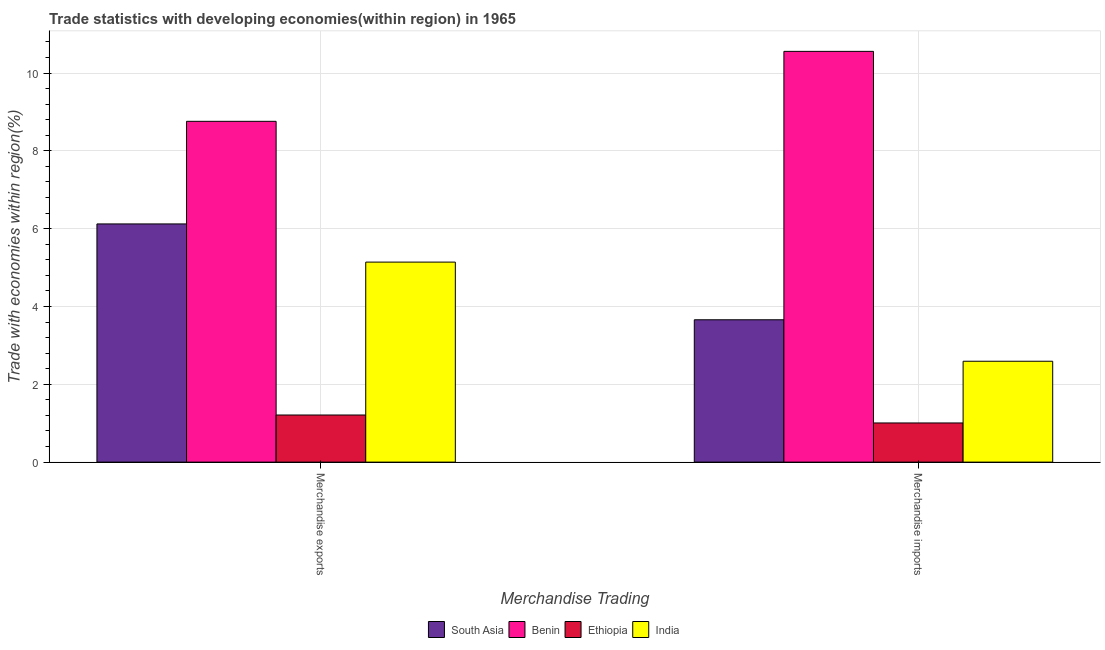How many different coloured bars are there?
Offer a terse response. 4. Are the number of bars on each tick of the X-axis equal?
Make the answer very short. Yes. What is the merchandise imports in South Asia?
Provide a short and direct response. 3.66. Across all countries, what is the maximum merchandise imports?
Ensure brevity in your answer.  10.56. Across all countries, what is the minimum merchandise exports?
Offer a very short reply. 1.21. In which country was the merchandise exports maximum?
Make the answer very short. Benin. In which country was the merchandise imports minimum?
Give a very brief answer. Ethiopia. What is the total merchandise exports in the graph?
Provide a short and direct response. 21.23. What is the difference between the merchandise exports in Benin and that in India?
Make the answer very short. 3.62. What is the difference between the merchandise exports in Benin and the merchandise imports in India?
Offer a terse response. 6.17. What is the average merchandise imports per country?
Your response must be concise. 4.45. What is the difference between the merchandise imports and merchandise exports in Benin?
Make the answer very short. 1.8. In how many countries, is the merchandise imports greater than 0.8 %?
Make the answer very short. 4. What is the ratio of the merchandise exports in Ethiopia to that in India?
Your response must be concise. 0.24. Is the merchandise exports in Ethiopia less than that in India?
Your response must be concise. Yes. What does the 4th bar from the left in Merchandise imports represents?
Give a very brief answer. India. What does the 4th bar from the right in Merchandise exports represents?
Provide a succinct answer. South Asia. How many bars are there?
Provide a succinct answer. 8. How many countries are there in the graph?
Your answer should be very brief. 4. Are the values on the major ticks of Y-axis written in scientific E-notation?
Give a very brief answer. No. Does the graph contain any zero values?
Offer a terse response. No. Where does the legend appear in the graph?
Provide a succinct answer. Bottom center. What is the title of the graph?
Your answer should be very brief. Trade statistics with developing economies(within region) in 1965. Does "Tajikistan" appear as one of the legend labels in the graph?
Provide a short and direct response. No. What is the label or title of the X-axis?
Provide a succinct answer. Merchandise Trading. What is the label or title of the Y-axis?
Offer a very short reply. Trade with economies within region(%). What is the Trade with economies within region(%) of South Asia in Merchandise exports?
Ensure brevity in your answer.  6.12. What is the Trade with economies within region(%) in Benin in Merchandise exports?
Your response must be concise. 8.76. What is the Trade with economies within region(%) of Ethiopia in Merchandise exports?
Your answer should be very brief. 1.21. What is the Trade with economies within region(%) in India in Merchandise exports?
Your answer should be compact. 5.14. What is the Trade with economies within region(%) in South Asia in Merchandise imports?
Offer a terse response. 3.66. What is the Trade with economies within region(%) of Benin in Merchandise imports?
Offer a terse response. 10.56. What is the Trade with economies within region(%) in Ethiopia in Merchandise imports?
Provide a short and direct response. 1.01. What is the Trade with economies within region(%) of India in Merchandise imports?
Your response must be concise. 2.59. Across all Merchandise Trading, what is the maximum Trade with economies within region(%) of South Asia?
Ensure brevity in your answer.  6.12. Across all Merchandise Trading, what is the maximum Trade with economies within region(%) in Benin?
Offer a terse response. 10.56. Across all Merchandise Trading, what is the maximum Trade with economies within region(%) of Ethiopia?
Provide a short and direct response. 1.21. Across all Merchandise Trading, what is the maximum Trade with economies within region(%) of India?
Offer a very short reply. 5.14. Across all Merchandise Trading, what is the minimum Trade with economies within region(%) in South Asia?
Your response must be concise. 3.66. Across all Merchandise Trading, what is the minimum Trade with economies within region(%) in Benin?
Ensure brevity in your answer.  8.76. Across all Merchandise Trading, what is the minimum Trade with economies within region(%) of Ethiopia?
Ensure brevity in your answer.  1.01. Across all Merchandise Trading, what is the minimum Trade with economies within region(%) of India?
Your answer should be very brief. 2.59. What is the total Trade with economies within region(%) of South Asia in the graph?
Your answer should be compact. 9.78. What is the total Trade with economies within region(%) in Benin in the graph?
Give a very brief answer. 19.32. What is the total Trade with economies within region(%) of Ethiopia in the graph?
Ensure brevity in your answer.  2.22. What is the total Trade with economies within region(%) in India in the graph?
Make the answer very short. 7.73. What is the difference between the Trade with economies within region(%) in South Asia in Merchandise exports and that in Merchandise imports?
Provide a succinct answer. 2.46. What is the difference between the Trade with economies within region(%) in Benin in Merchandise exports and that in Merchandise imports?
Offer a terse response. -1.8. What is the difference between the Trade with economies within region(%) of Ethiopia in Merchandise exports and that in Merchandise imports?
Your answer should be very brief. 0.2. What is the difference between the Trade with economies within region(%) in India in Merchandise exports and that in Merchandise imports?
Make the answer very short. 2.55. What is the difference between the Trade with economies within region(%) in South Asia in Merchandise exports and the Trade with economies within region(%) in Benin in Merchandise imports?
Your answer should be very brief. -4.44. What is the difference between the Trade with economies within region(%) of South Asia in Merchandise exports and the Trade with economies within region(%) of Ethiopia in Merchandise imports?
Ensure brevity in your answer.  5.12. What is the difference between the Trade with economies within region(%) of South Asia in Merchandise exports and the Trade with economies within region(%) of India in Merchandise imports?
Offer a very short reply. 3.53. What is the difference between the Trade with economies within region(%) of Benin in Merchandise exports and the Trade with economies within region(%) of Ethiopia in Merchandise imports?
Your answer should be compact. 7.75. What is the difference between the Trade with economies within region(%) in Benin in Merchandise exports and the Trade with economies within region(%) in India in Merchandise imports?
Ensure brevity in your answer.  6.17. What is the difference between the Trade with economies within region(%) of Ethiopia in Merchandise exports and the Trade with economies within region(%) of India in Merchandise imports?
Your response must be concise. -1.38. What is the average Trade with economies within region(%) in South Asia per Merchandise Trading?
Ensure brevity in your answer.  4.89. What is the average Trade with economies within region(%) in Benin per Merchandise Trading?
Keep it short and to the point. 9.66. What is the average Trade with economies within region(%) in Ethiopia per Merchandise Trading?
Offer a very short reply. 1.11. What is the average Trade with economies within region(%) in India per Merchandise Trading?
Your response must be concise. 3.87. What is the difference between the Trade with economies within region(%) of South Asia and Trade with economies within region(%) of Benin in Merchandise exports?
Your response must be concise. -2.64. What is the difference between the Trade with economies within region(%) of South Asia and Trade with economies within region(%) of Ethiopia in Merchandise exports?
Ensure brevity in your answer.  4.91. What is the difference between the Trade with economies within region(%) in South Asia and Trade with economies within region(%) in India in Merchandise exports?
Make the answer very short. 0.98. What is the difference between the Trade with economies within region(%) in Benin and Trade with economies within region(%) in Ethiopia in Merchandise exports?
Ensure brevity in your answer.  7.55. What is the difference between the Trade with economies within region(%) in Benin and Trade with economies within region(%) in India in Merchandise exports?
Offer a very short reply. 3.62. What is the difference between the Trade with economies within region(%) of Ethiopia and Trade with economies within region(%) of India in Merchandise exports?
Your answer should be very brief. -3.93. What is the difference between the Trade with economies within region(%) in South Asia and Trade with economies within region(%) in Benin in Merchandise imports?
Offer a terse response. -6.9. What is the difference between the Trade with economies within region(%) of South Asia and Trade with economies within region(%) of Ethiopia in Merchandise imports?
Provide a succinct answer. 2.65. What is the difference between the Trade with economies within region(%) in South Asia and Trade with economies within region(%) in India in Merchandise imports?
Offer a very short reply. 1.07. What is the difference between the Trade with economies within region(%) of Benin and Trade with economies within region(%) of Ethiopia in Merchandise imports?
Give a very brief answer. 9.55. What is the difference between the Trade with economies within region(%) in Benin and Trade with economies within region(%) in India in Merchandise imports?
Provide a short and direct response. 7.96. What is the difference between the Trade with economies within region(%) in Ethiopia and Trade with economies within region(%) in India in Merchandise imports?
Ensure brevity in your answer.  -1.59. What is the ratio of the Trade with economies within region(%) of South Asia in Merchandise exports to that in Merchandise imports?
Your response must be concise. 1.67. What is the ratio of the Trade with economies within region(%) of Benin in Merchandise exports to that in Merchandise imports?
Ensure brevity in your answer.  0.83. What is the ratio of the Trade with economies within region(%) of Ethiopia in Merchandise exports to that in Merchandise imports?
Provide a short and direct response. 1.2. What is the ratio of the Trade with economies within region(%) of India in Merchandise exports to that in Merchandise imports?
Your answer should be compact. 1.98. What is the difference between the highest and the second highest Trade with economies within region(%) in South Asia?
Your answer should be compact. 2.46. What is the difference between the highest and the second highest Trade with economies within region(%) of Benin?
Give a very brief answer. 1.8. What is the difference between the highest and the second highest Trade with economies within region(%) in Ethiopia?
Give a very brief answer. 0.2. What is the difference between the highest and the second highest Trade with economies within region(%) in India?
Give a very brief answer. 2.55. What is the difference between the highest and the lowest Trade with economies within region(%) in South Asia?
Your response must be concise. 2.46. What is the difference between the highest and the lowest Trade with economies within region(%) in Benin?
Your answer should be very brief. 1.8. What is the difference between the highest and the lowest Trade with economies within region(%) in Ethiopia?
Offer a terse response. 0.2. What is the difference between the highest and the lowest Trade with economies within region(%) of India?
Your answer should be very brief. 2.55. 